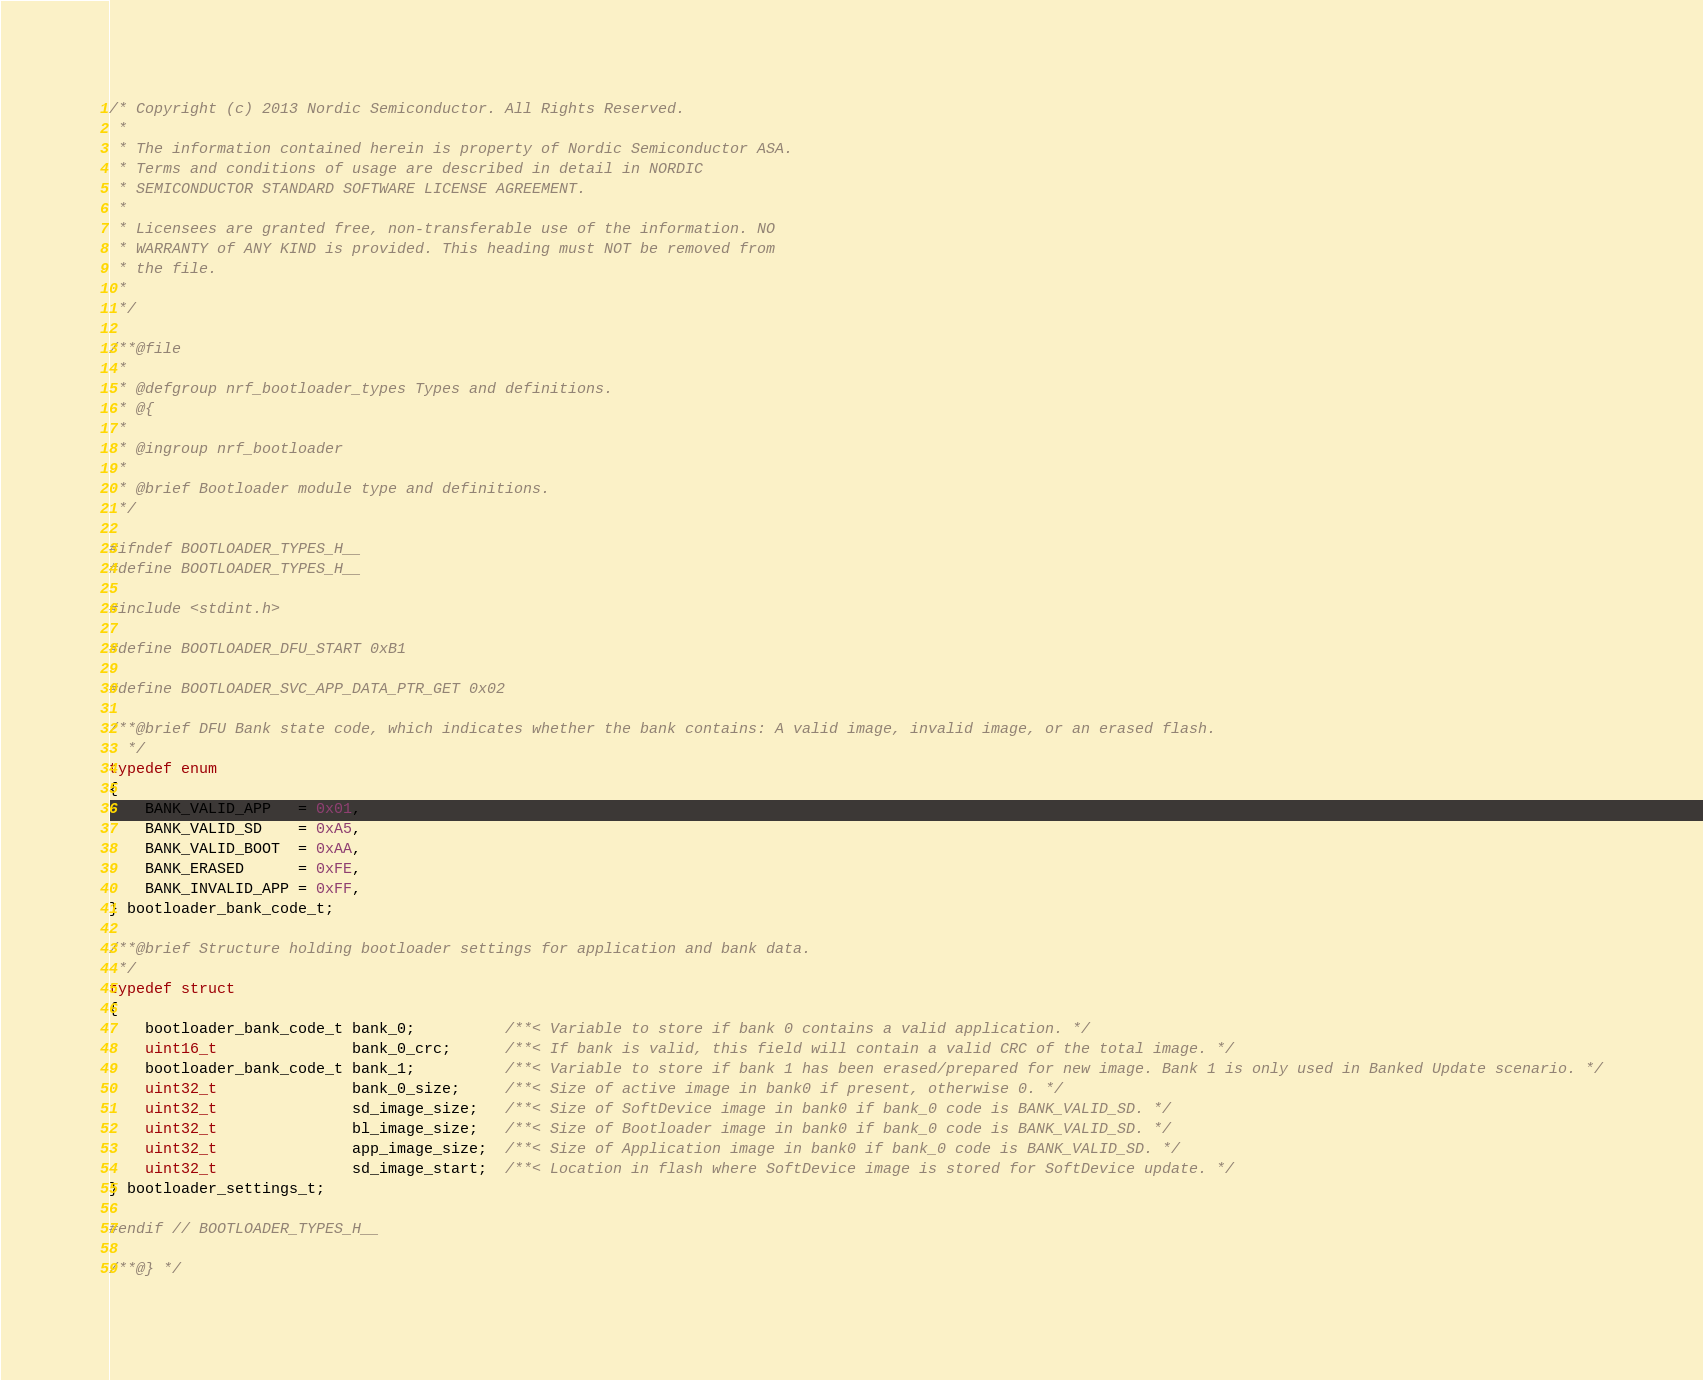<code> <loc_0><loc_0><loc_500><loc_500><_C_>/* Copyright (c) 2013 Nordic Semiconductor. All Rights Reserved.
 *
 * The information contained herein is property of Nordic Semiconductor ASA.
 * Terms and conditions of usage are described in detail in NORDIC
 * SEMICONDUCTOR STANDARD SOFTWARE LICENSE AGREEMENT.
 *
 * Licensees are granted free, non-transferable use of the information. NO
 * WARRANTY of ANY KIND is provided. This heading must NOT be removed from
 * the file.
 *
 */
 
/**@file
 *
 * @defgroup nrf_bootloader_types Types and definitions.
 * @{     
 *  
 * @ingroup nrf_bootloader
 * 
 * @brief Bootloader module type and definitions.
 */
 
#ifndef BOOTLOADER_TYPES_H__
#define BOOTLOADER_TYPES_H__

#include <stdint.h>

#define BOOTLOADER_DFU_START 0xB1

#define BOOTLOADER_SVC_APP_DATA_PTR_GET 0x02

/**@brief DFU Bank state code, which indicates whether the bank contains: A valid image, invalid image, or an erased flash.
  */
typedef enum
{
    BANK_VALID_APP   = 0x01,
    BANK_VALID_SD    = 0xA5,
    BANK_VALID_BOOT  = 0xAA,
    BANK_ERASED      = 0xFE,
    BANK_INVALID_APP = 0xFF,
} bootloader_bank_code_t;

/**@brief Structure holding bootloader settings for application and bank data.
 */
typedef struct
{
    bootloader_bank_code_t bank_0;          /**< Variable to store if bank 0 contains a valid application. */
    uint16_t               bank_0_crc;      /**< If bank is valid, this field will contain a valid CRC of the total image. */
    bootloader_bank_code_t bank_1;          /**< Variable to store if bank 1 has been erased/prepared for new image. Bank 1 is only used in Banked Update scenario. */
    uint32_t               bank_0_size;     /**< Size of active image in bank0 if present, otherwise 0. */
    uint32_t               sd_image_size;   /**< Size of SoftDevice image in bank0 if bank_0 code is BANK_VALID_SD. */
    uint32_t               bl_image_size;   /**< Size of Bootloader image in bank0 if bank_0 code is BANK_VALID_SD. */
    uint32_t               app_image_size;  /**< Size of Application image in bank0 if bank_0 code is BANK_VALID_SD. */
    uint32_t               sd_image_start;  /**< Location in flash where SoftDevice image is stored for SoftDevice update. */
} bootloader_settings_t;

#endif // BOOTLOADER_TYPES_H__ 

/**@} */
</code> 